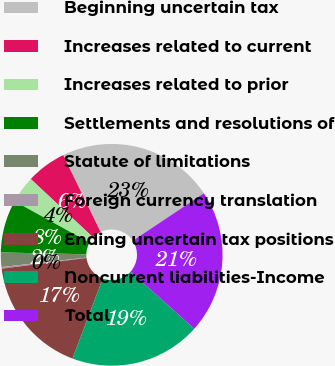Convert chart. <chart><loc_0><loc_0><loc_500><loc_500><pie_chart><fcel>Beginning uncertain tax<fcel>Increases related to current<fcel>Increases related to prior<fcel>Settlements and resolutions of<fcel>Statute of limitations<fcel>Foreign currency translation<fcel>Ending uncertain tax positions<fcel>Noncurrent liabilities-Income<fcel>Total<nl><fcel>22.84%<fcel>5.82%<fcel>3.96%<fcel>7.68%<fcel>2.1%<fcel>0.24%<fcel>17.26%<fcel>19.12%<fcel>20.98%<nl></chart> 